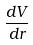Convert formula to latex. <formula><loc_0><loc_0><loc_500><loc_500>\frac { d V } { d r }</formula> 